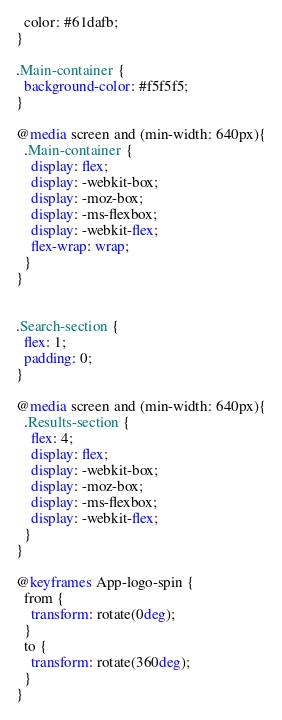<code> <loc_0><loc_0><loc_500><loc_500><_CSS_>  color: #61dafb;
}

.Main-container {
  background-color: #f5f5f5;
}

@media screen and (min-width: 640px){
  .Main-container {
    display: flex;
    display: -webkit-box; 
    display: -moz-box;
    display: -ms-flexbox;
    display: -webkit-flex;
    flex-wrap: wrap;
  }    
}


.Search-section {
  flex: 1;
  padding: 0;
}

@media screen and (min-width: 640px){
  .Results-section {
    flex: 4;
    display: flex;
    display: -webkit-box; 
    display: -moz-box;
    display: -ms-flexbox;
    display: -webkit-flex;
  }
}

@keyframes App-logo-spin {
  from {
    transform: rotate(0deg);
  }
  to {
    transform: rotate(360deg);
  }
}
</code> 